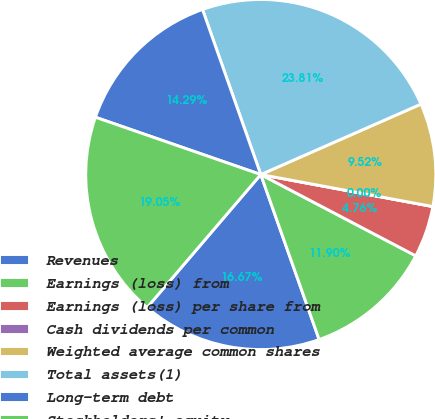<chart> <loc_0><loc_0><loc_500><loc_500><pie_chart><fcel>Revenues<fcel>Earnings (loss) from<fcel>Earnings (loss) per share from<fcel>Cash dividends per common<fcel>Weighted average common shares<fcel>Total assets(1)<fcel>Long-term debt<fcel>Stockholders' equity<nl><fcel>16.67%<fcel>11.9%<fcel>4.76%<fcel>0.0%<fcel>9.52%<fcel>23.81%<fcel>14.29%<fcel>19.05%<nl></chart> 